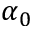Convert formula to latex. <formula><loc_0><loc_0><loc_500><loc_500>\alpha _ { 0 }</formula> 